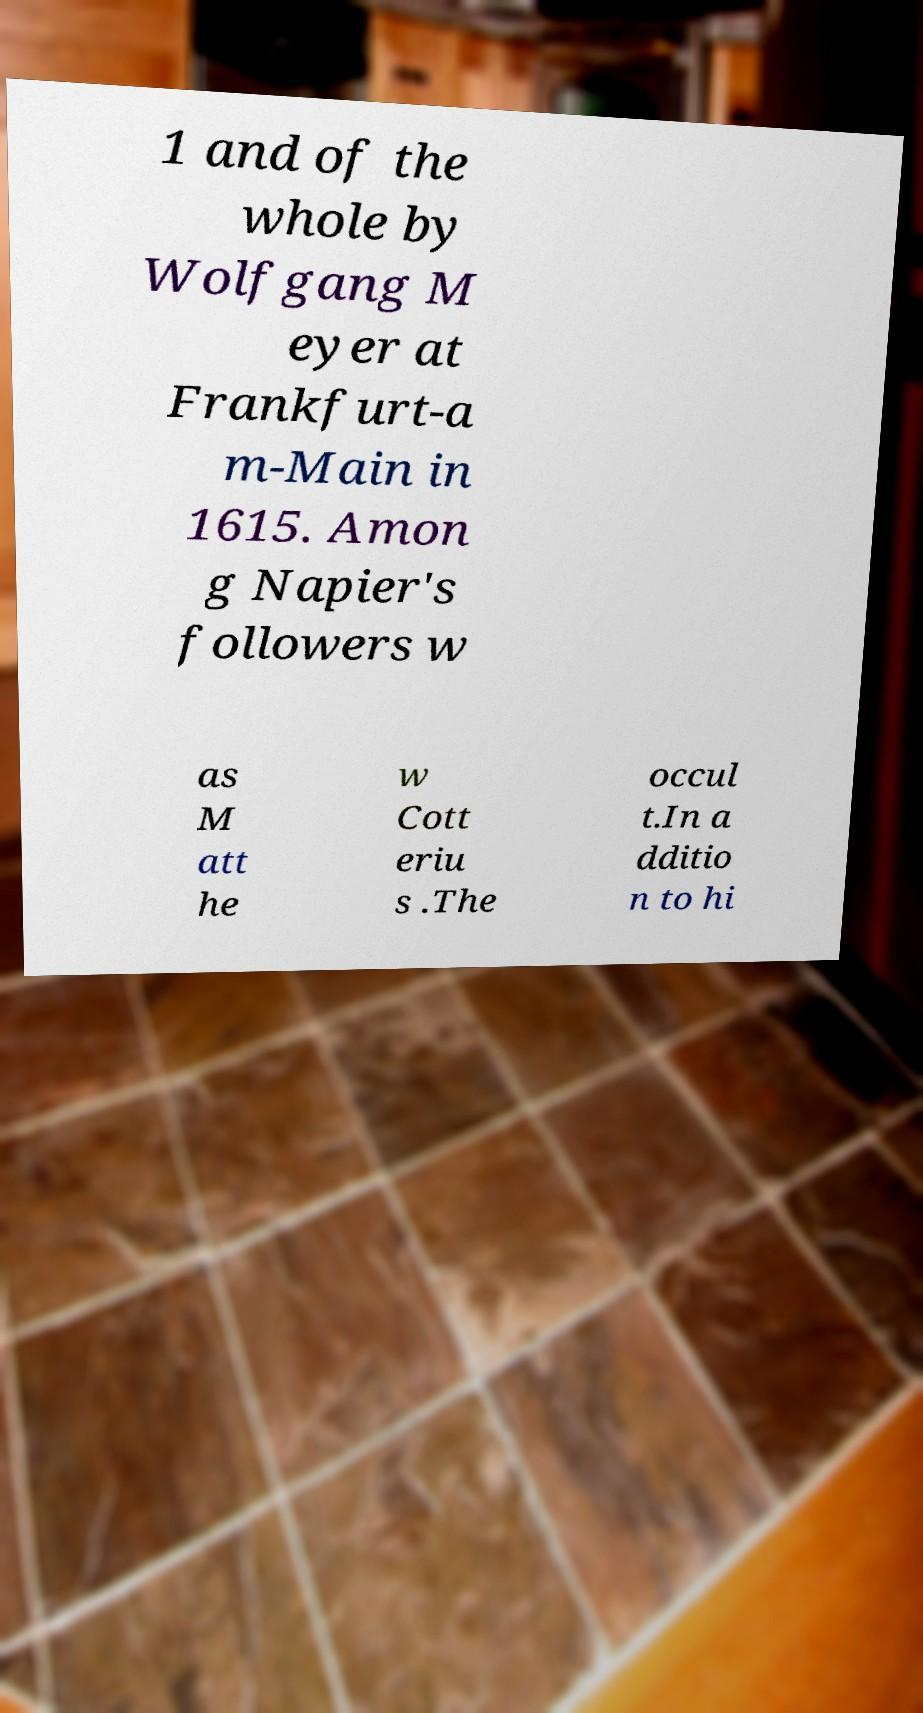Please identify and transcribe the text found in this image. 1 and of the whole by Wolfgang M eyer at Frankfurt-a m-Main in 1615. Amon g Napier's followers w as M att he w Cott eriu s .The occul t.In a dditio n to hi 